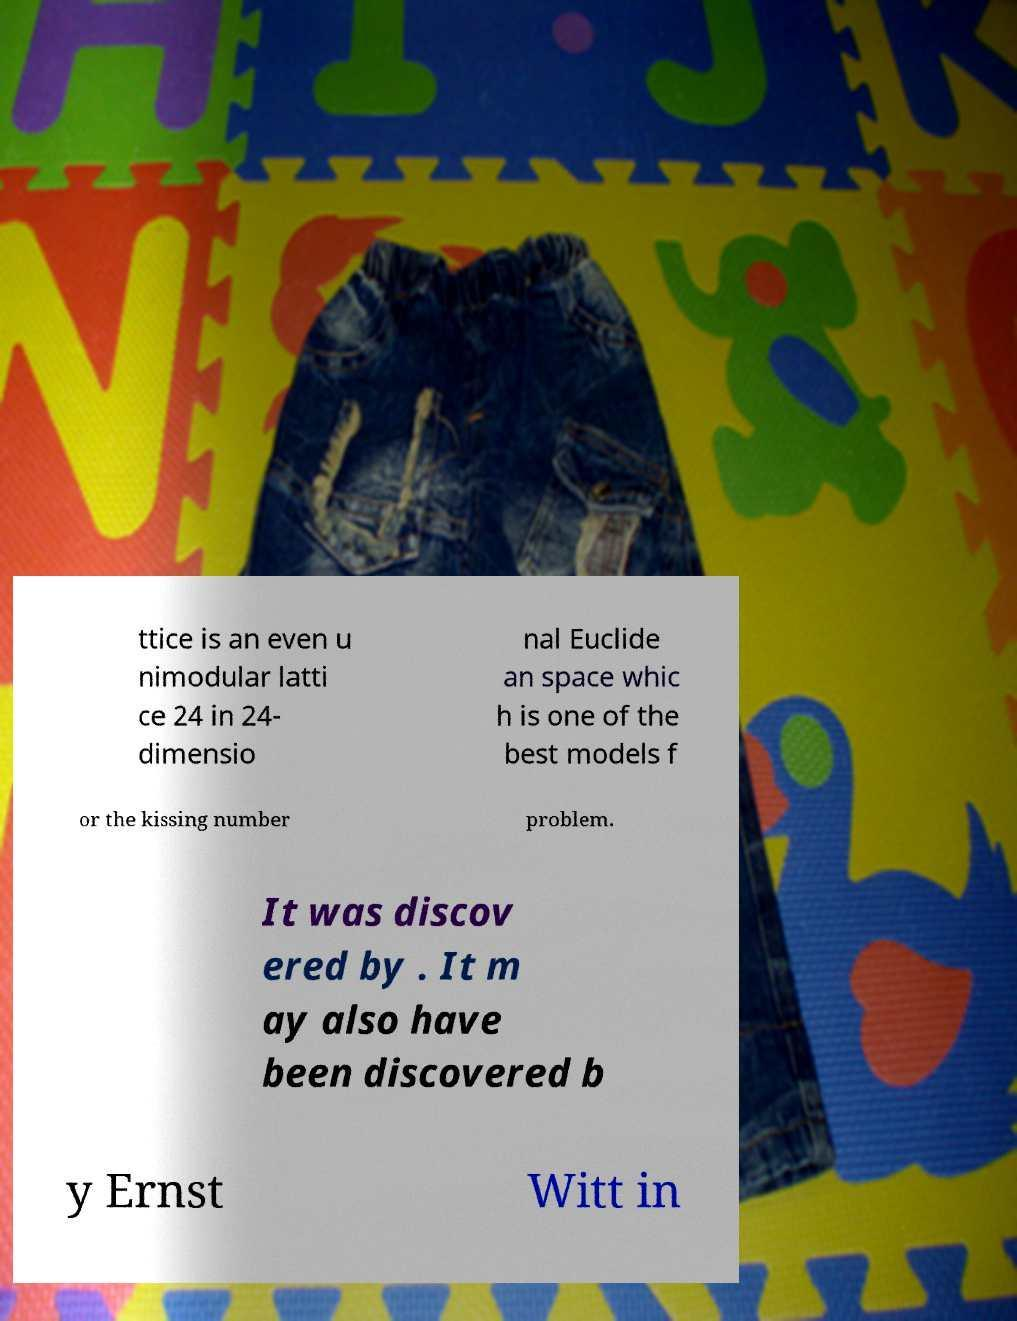Could you extract and type out the text from this image? ttice is an even u nimodular latti ce 24 in 24- dimensio nal Euclide an space whic h is one of the best models f or the kissing number problem. It was discov ered by . It m ay also have been discovered b y Ernst Witt in 